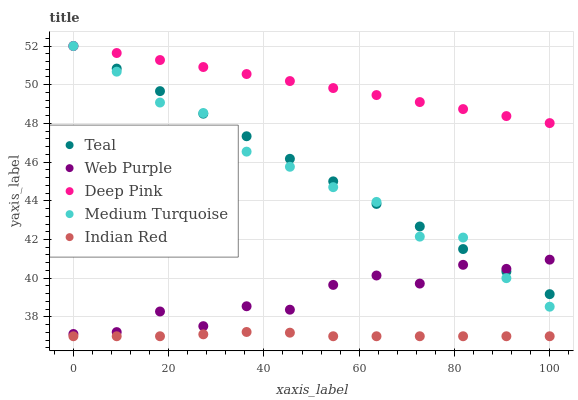Does Indian Red have the minimum area under the curve?
Answer yes or no. Yes. Does Deep Pink have the maximum area under the curve?
Answer yes or no. Yes. Does Web Purple have the minimum area under the curve?
Answer yes or no. No. Does Web Purple have the maximum area under the curve?
Answer yes or no. No. Is Teal the smoothest?
Answer yes or no. Yes. Is Web Purple the roughest?
Answer yes or no. Yes. Is Deep Pink the smoothest?
Answer yes or no. No. Is Deep Pink the roughest?
Answer yes or no. No. Does Indian Red have the lowest value?
Answer yes or no. Yes. Does Web Purple have the lowest value?
Answer yes or no. No. Does Teal have the highest value?
Answer yes or no. Yes. Does Web Purple have the highest value?
Answer yes or no. No. Is Indian Red less than Web Purple?
Answer yes or no. Yes. Is Web Purple greater than Indian Red?
Answer yes or no. Yes. Does Medium Turquoise intersect Web Purple?
Answer yes or no. Yes. Is Medium Turquoise less than Web Purple?
Answer yes or no. No. Is Medium Turquoise greater than Web Purple?
Answer yes or no. No. Does Indian Red intersect Web Purple?
Answer yes or no. No. 